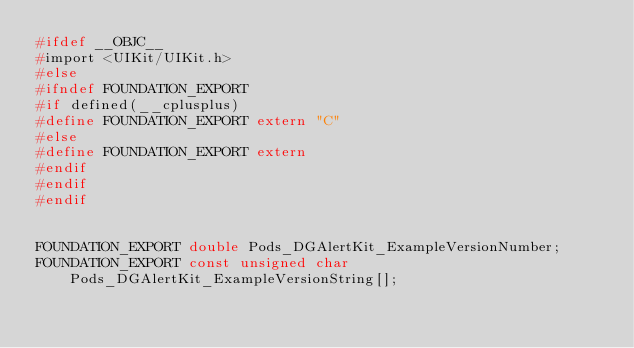<code> <loc_0><loc_0><loc_500><loc_500><_C_>#ifdef __OBJC__
#import <UIKit/UIKit.h>
#else
#ifndef FOUNDATION_EXPORT
#if defined(__cplusplus)
#define FOUNDATION_EXPORT extern "C"
#else
#define FOUNDATION_EXPORT extern
#endif
#endif
#endif


FOUNDATION_EXPORT double Pods_DGAlertKit_ExampleVersionNumber;
FOUNDATION_EXPORT const unsigned char Pods_DGAlertKit_ExampleVersionString[];

</code> 